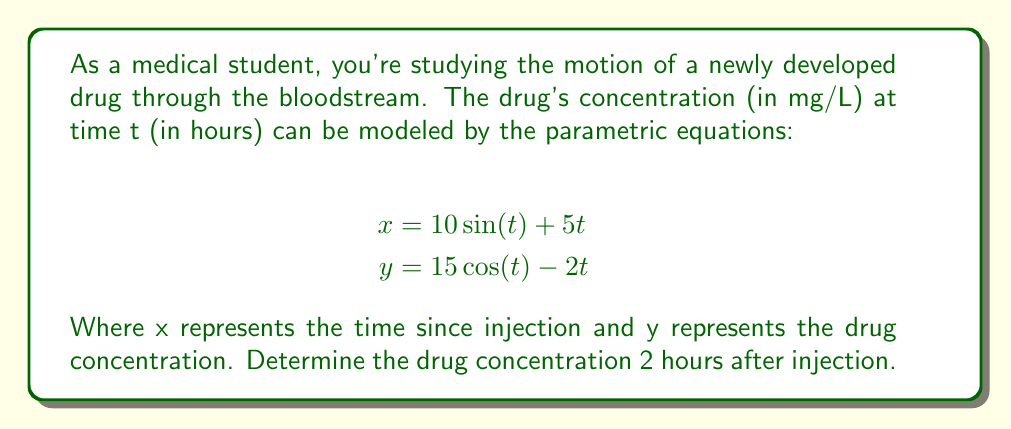Give your solution to this math problem. To solve this problem, we need to follow these steps:

1) First, we need to find the value of x when t = 2 hours:
   $$x = 10\sin(2) + 5(2)$$
   $$x = 10\sin(2) + 10$$

2) Next, we need to find the value of y when t = 2 hours:
   $$y = 15\cos(2) - 2(2)$$
   $$y = 15\cos(2) - 4$$

3) The value of y at t = 2 gives us the drug concentration 2 hours after injection.

4) Let's calculate these values:
   $$\sin(2) \approx 0.9093$$
   $$\cos(2) \approx -0.4161$$

5) Substituting these values:
   $$x = 10(0.9093) + 10 \approx 19.093$$
   $$y = 15(-0.4161) - 4 \approx -10.2415$$

6) The x value confirms that we're at approximately 19.093 hours since injection, which isn't relevant to our question.

7) The y value, -10.2415, represents the drug concentration at t = 2 hours.

Therefore, the drug concentration 2 hours after injection is approximately -10.2415 mg/L.

Note: A negative concentration doesn't make physical sense in this context. This could indicate that the model has limitations or is only valid for certain time intervals. In a real-world scenario, you would need to consider these limitations and possibly adjust the model or its interpretation.
Answer: The drug concentration 2 hours after injection is approximately -10.2415 mg/L. 